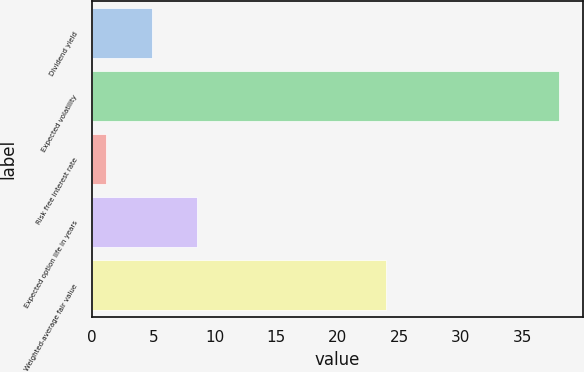<chart> <loc_0><loc_0><loc_500><loc_500><bar_chart><fcel>Dividend yield<fcel>Expected volatility<fcel>Risk free interest rate<fcel>Expected option life in years<fcel>Weighted-average fair value<nl><fcel>4.88<fcel>38<fcel>1.2<fcel>8.56<fcel>23.93<nl></chart> 